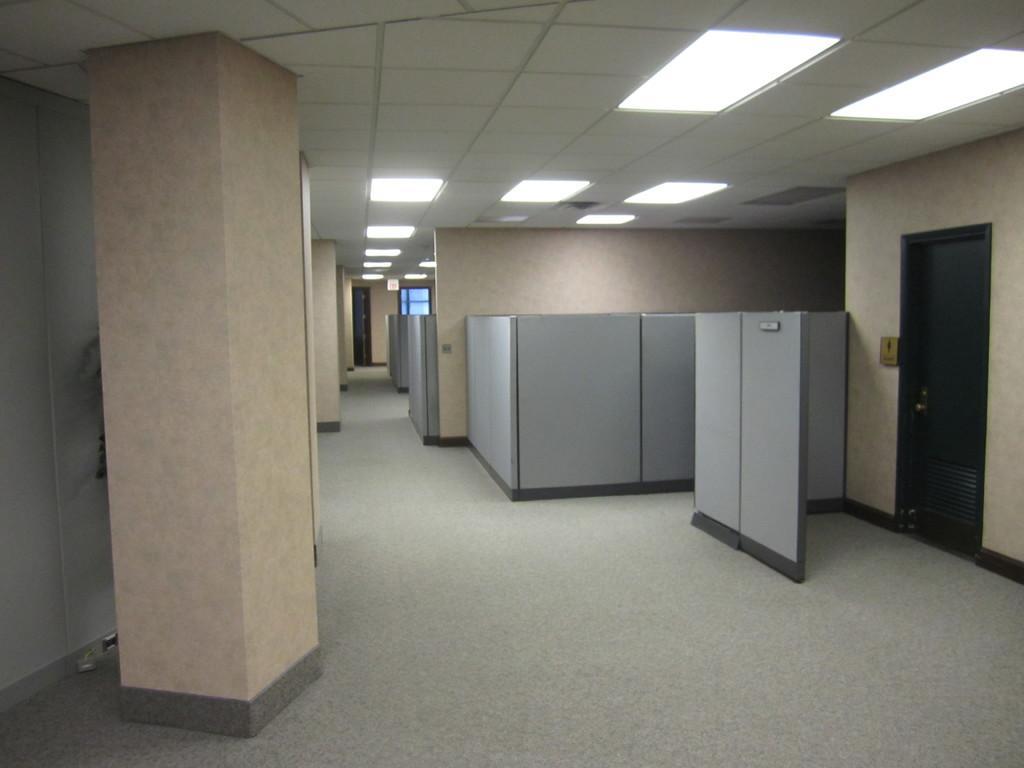Please provide a concise description of this image. In the center of the image there is a wall, door, pillars, lights and a few other objects. 